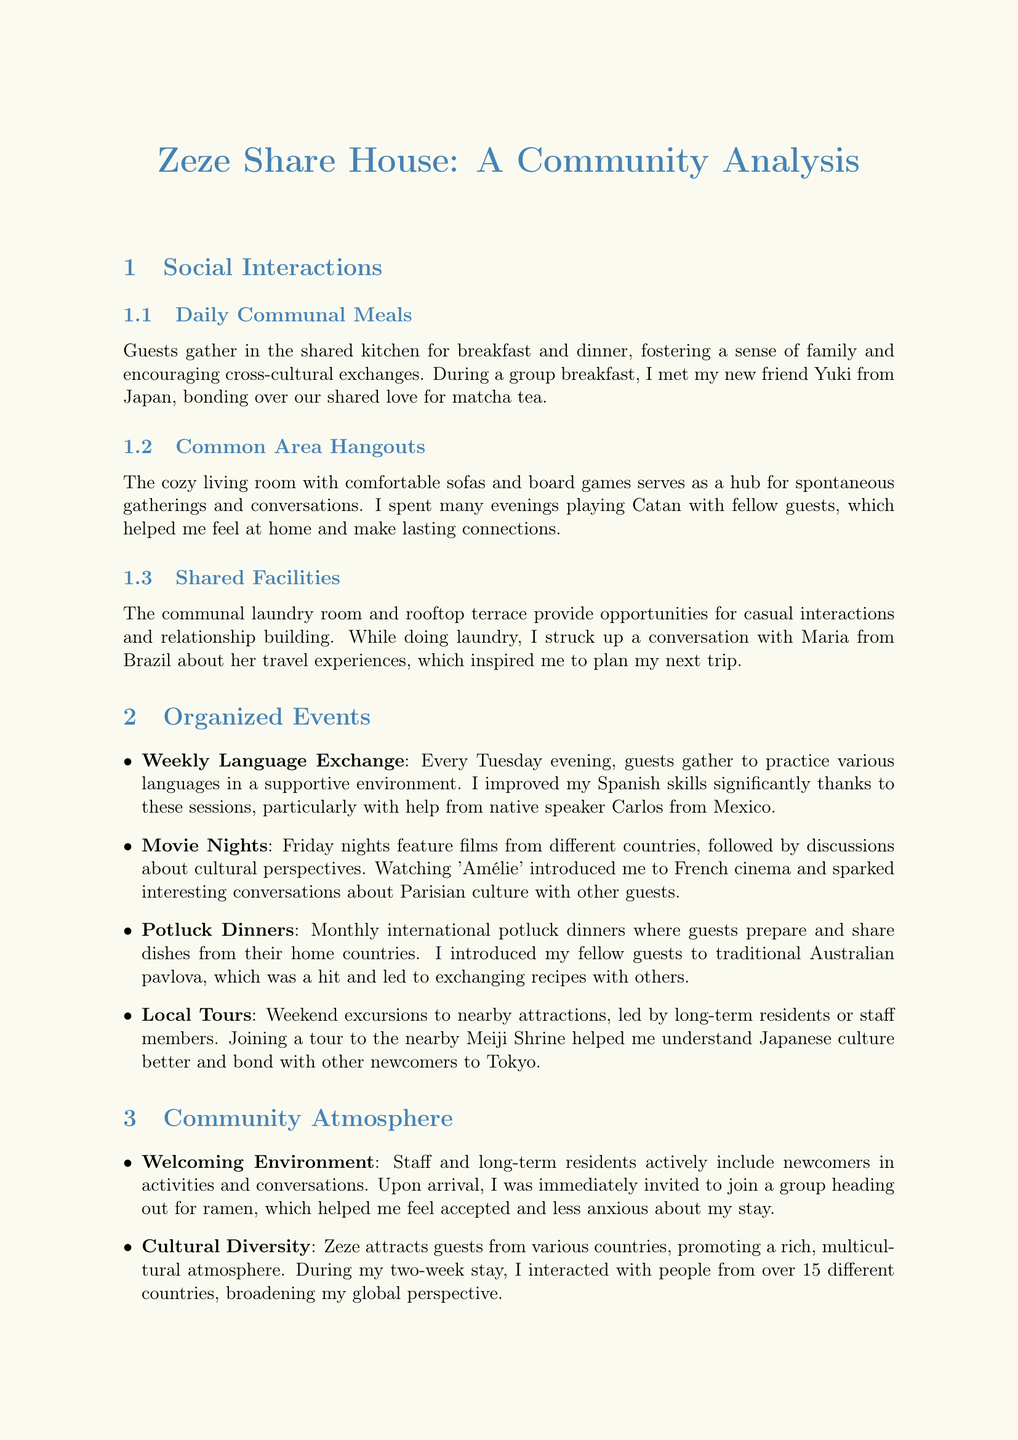what is the main focus of Zeze Share House? The document analyzes social interactions and events organized at Zeze, highlighting the community atmosphere.
Answer: community atmosphere how often are potluck dinners held at Zeze? The document states that potluck dinners occur monthly.
Answer: monthly who helped improve the author's Spanish skills? The author credits Carlos from Mexico for helping improve their Spanish skills during the language exchange sessions.
Answer: Carlos from Mexico what is the atmosphere described at Zeze in terms of cultural interaction? The document mentions that Zeze attracts guests from various countries, promoting a rich, multicultural atmosphere.
Answer: multicultural atmosphere what factor contributed to the author's decision to extend their stay? The author chose to extend their stay due to the friendships formed and the engaging community.
Answer: friendships formed and engaging community how many countries did the author interact with during their stay? The author interacted with people from over 15 different countries during their stay.
Answer: over 15 what type of gatherings occur in the cozy living room? The document mentions that the cozy living room serves as a hub for spontaneous gatherings and conversations.
Answer: spontaneous gatherings what is a common challenge shared among guests? The document states that guests bond over the complexities of living in a new country, which creates a sense of camaraderie.
Answer: complexities of living in a new country which organized event features films from different countries? The document specifies that movie nights feature films from different countries.
Answer: movie nights how does Zeze's community support local integration? The community helps guests feel more connected to the local area and culture through tips from long-term residents.
Answer: tips from long-term residents 